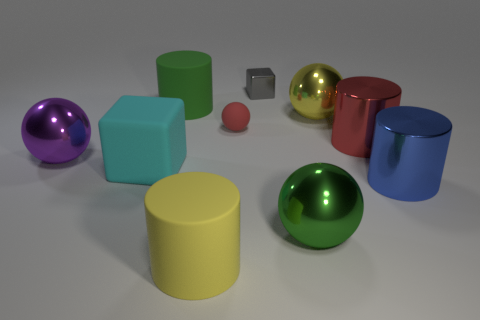What number of other things are the same size as the gray metallic thing?
Offer a very short reply. 1. Are there the same number of green metal objects right of the red metallic cylinder and large shiny spheres that are to the left of the purple sphere?
Your response must be concise. Yes. What color is the matte object that is the same shape as the big yellow metallic object?
Your response must be concise. Red. Do the metallic cylinder that is behind the cyan rubber block and the rubber sphere have the same color?
Your response must be concise. Yes. What size is the red matte thing that is the same shape as the green metallic thing?
Keep it short and to the point. Small. How many other large cylinders are the same material as the large green cylinder?
Ensure brevity in your answer.  1. There is a big rubber object that is on the left side of the big matte object behind the small matte ball; is there a large blue cylinder that is behind it?
Keep it short and to the point. No. What is the shape of the large blue object?
Your response must be concise. Cylinder. Is the large green object in front of the blue metallic cylinder made of the same material as the large green thing behind the cyan thing?
Your answer should be very brief. No. How many metal cubes are the same color as the tiny ball?
Ensure brevity in your answer.  0. 